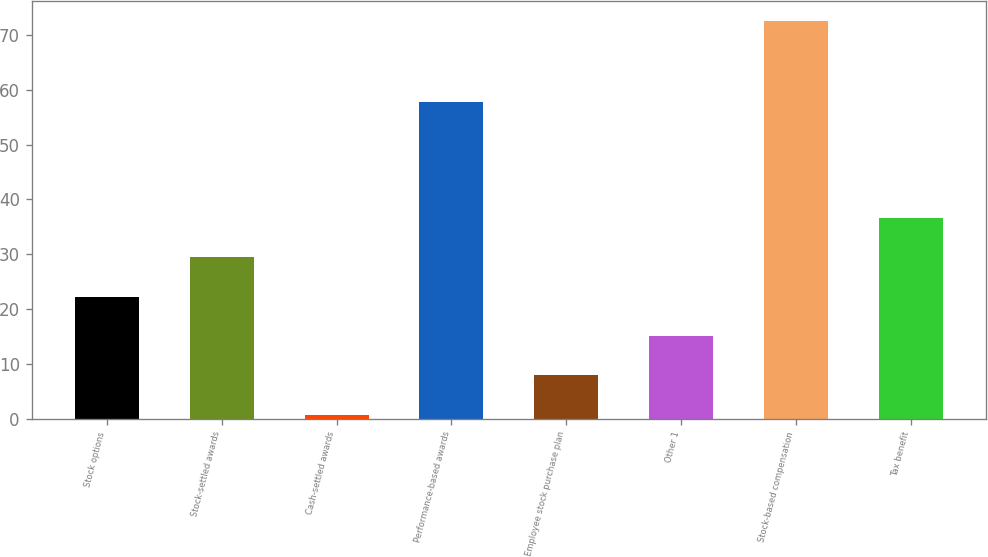Convert chart. <chart><loc_0><loc_0><loc_500><loc_500><bar_chart><fcel>Stock options<fcel>Stock-settled awards<fcel>Cash-settled awards<fcel>Performance-based awards<fcel>Employee stock purchase plan<fcel>Other 1<fcel>Stock-based compensation<fcel>Tax benefit<nl><fcel>22.27<fcel>29.46<fcel>0.7<fcel>57.7<fcel>7.89<fcel>15.08<fcel>72.6<fcel>36.65<nl></chart> 